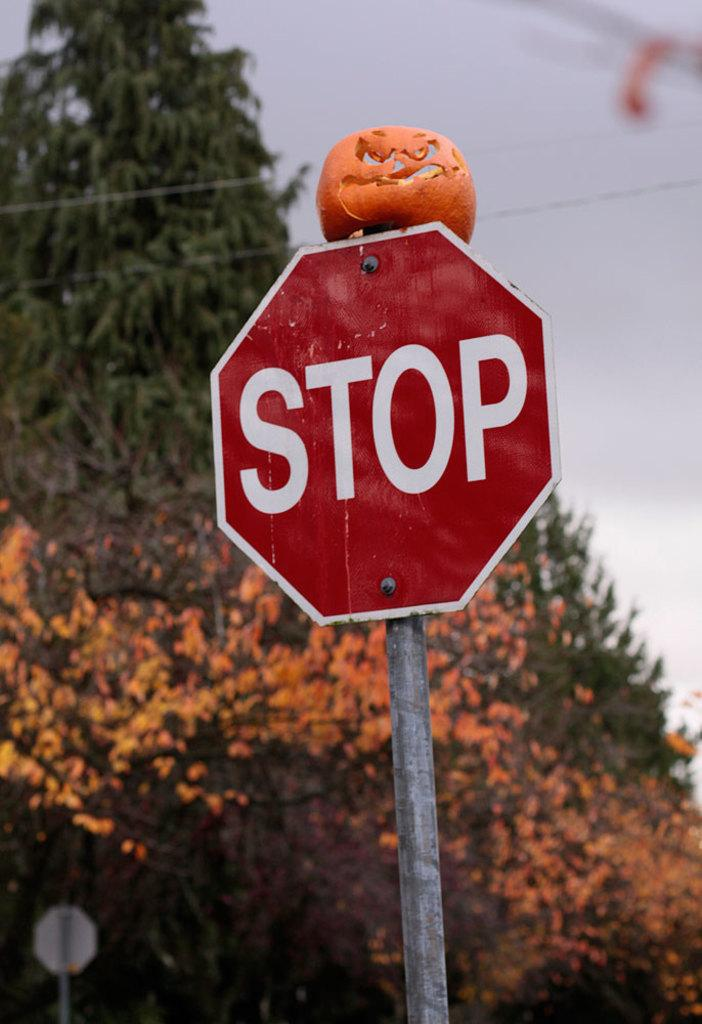Provide a one-sentence caption for the provided image. A carved pumpkin is on top of a red sign that says Stop. 